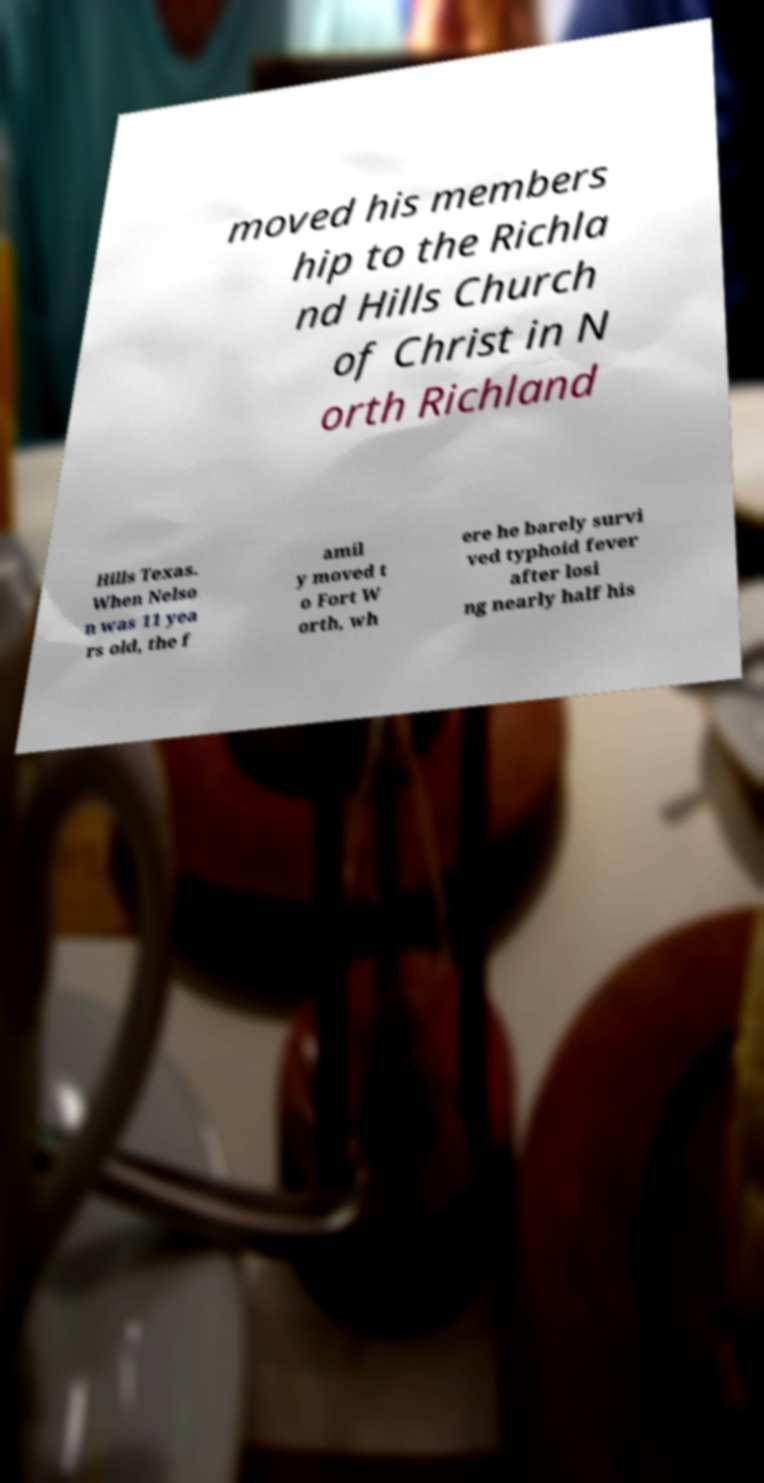Could you assist in decoding the text presented in this image and type it out clearly? moved his members hip to the Richla nd Hills Church of Christ in N orth Richland Hills Texas. When Nelso n was 11 yea rs old, the f amil y moved t o Fort W orth, wh ere he barely survi ved typhoid fever after losi ng nearly half his 